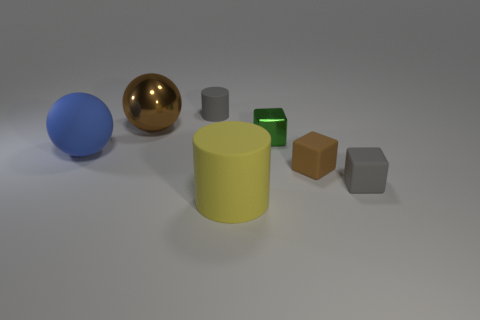There is a metallic object right of the gray cylinder; is there a big yellow matte cylinder that is in front of it?
Your response must be concise. Yes. What number of objects are either small yellow cubes or small gray matte objects?
Give a very brief answer. 2. There is a object that is both in front of the small brown matte thing and right of the yellow cylinder; what shape is it?
Ensure brevity in your answer.  Cube. Does the cylinder that is behind the big yellow rubber cylinder have the same material as the brown sphere?
Provide a succinct answer. No. What number of objects are big brown balls or metal objects that are to the left of the small green metallic block?
Your response must be concise. 1. The other cylinder that is made of the same material as the big yellow cylinder is what color?
Keep it short and to the point. Gray. What number of tiny gray cubes have the same material as the yellow cylinder?
Provide a short and direct response. 1. What number of large blue matte objects are there?
Provide a succinct answer. 1. There is a metal object on the left side of the small green block; does it have the same color as the big matte object in front of the blue rubber thing?
Offer a terse response. No. There is a yellow matte object; what number of gray objects are on the left side of it?
Provide a succinct answer. 1. 